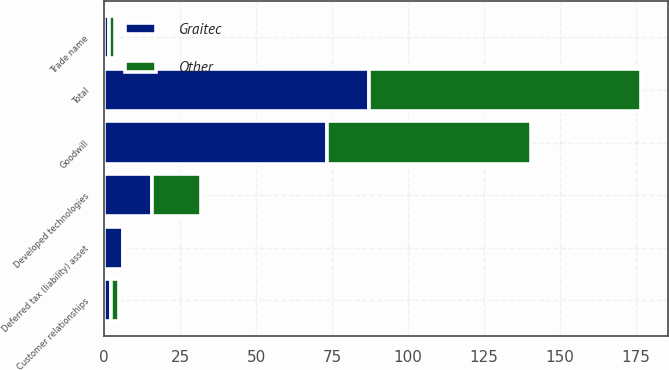Convert chart. <chart><loc_0><loc_0><loc_500><loc_500><stacked_bar_chart><ecel><fcel>Developed technologies<fcel>Customer relationships<fcel>Trade name<fcel>Goodwill<fcel>Deferred tax (liability) asset<fcel>Total<nl><fcel>Graitec<fcel>15.9<fcel>2.2<fcel>1.7<fcel>73.4<fcel>6.2<fcel>87<nl><fcel>Other<fcel>15.9<fcel>2.8<fcel>1.8<fcel>67<fcel>0.7<fcel>89.7<nl></chart> 